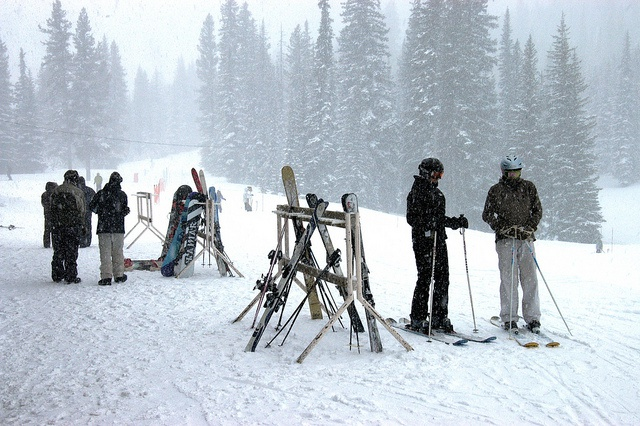Describe the objects in this image and their specific colors. I can see people in white, black, gray, and darkgray tones, people in white, black, gray, and darkgray tones, people in white, black, gray, and darkgray tones, people in white, black, gray, and darkgray tones, and skis in white, black, gray, and darkgray tones in this image. 